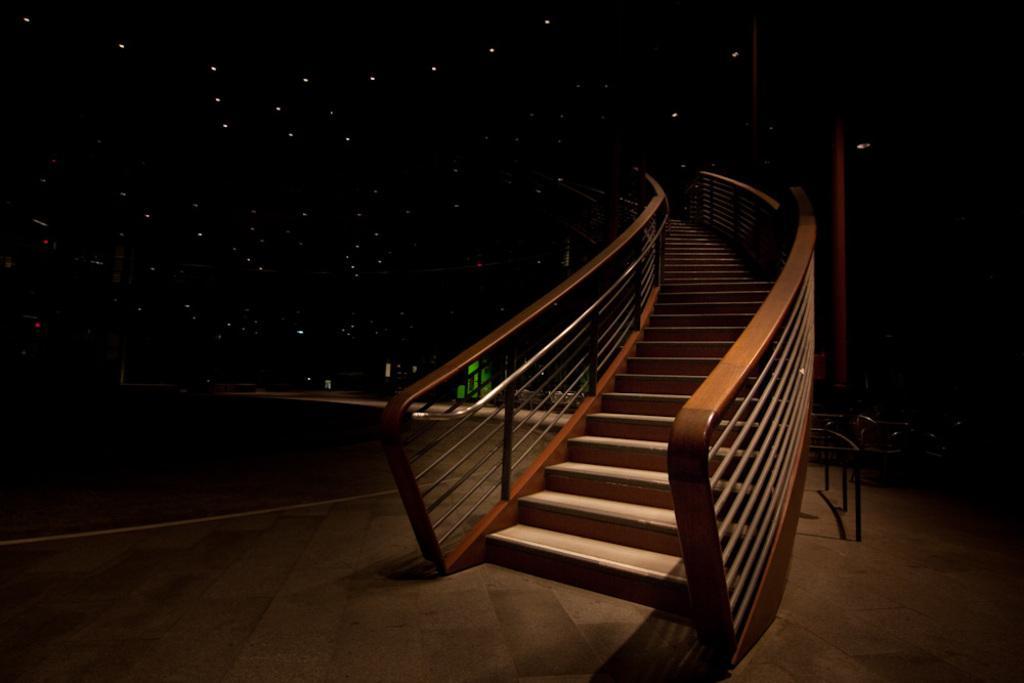Could you give a brief overview of what you see in this image? In this image I can see stairs and the background is in black color, I can also see few lights. 